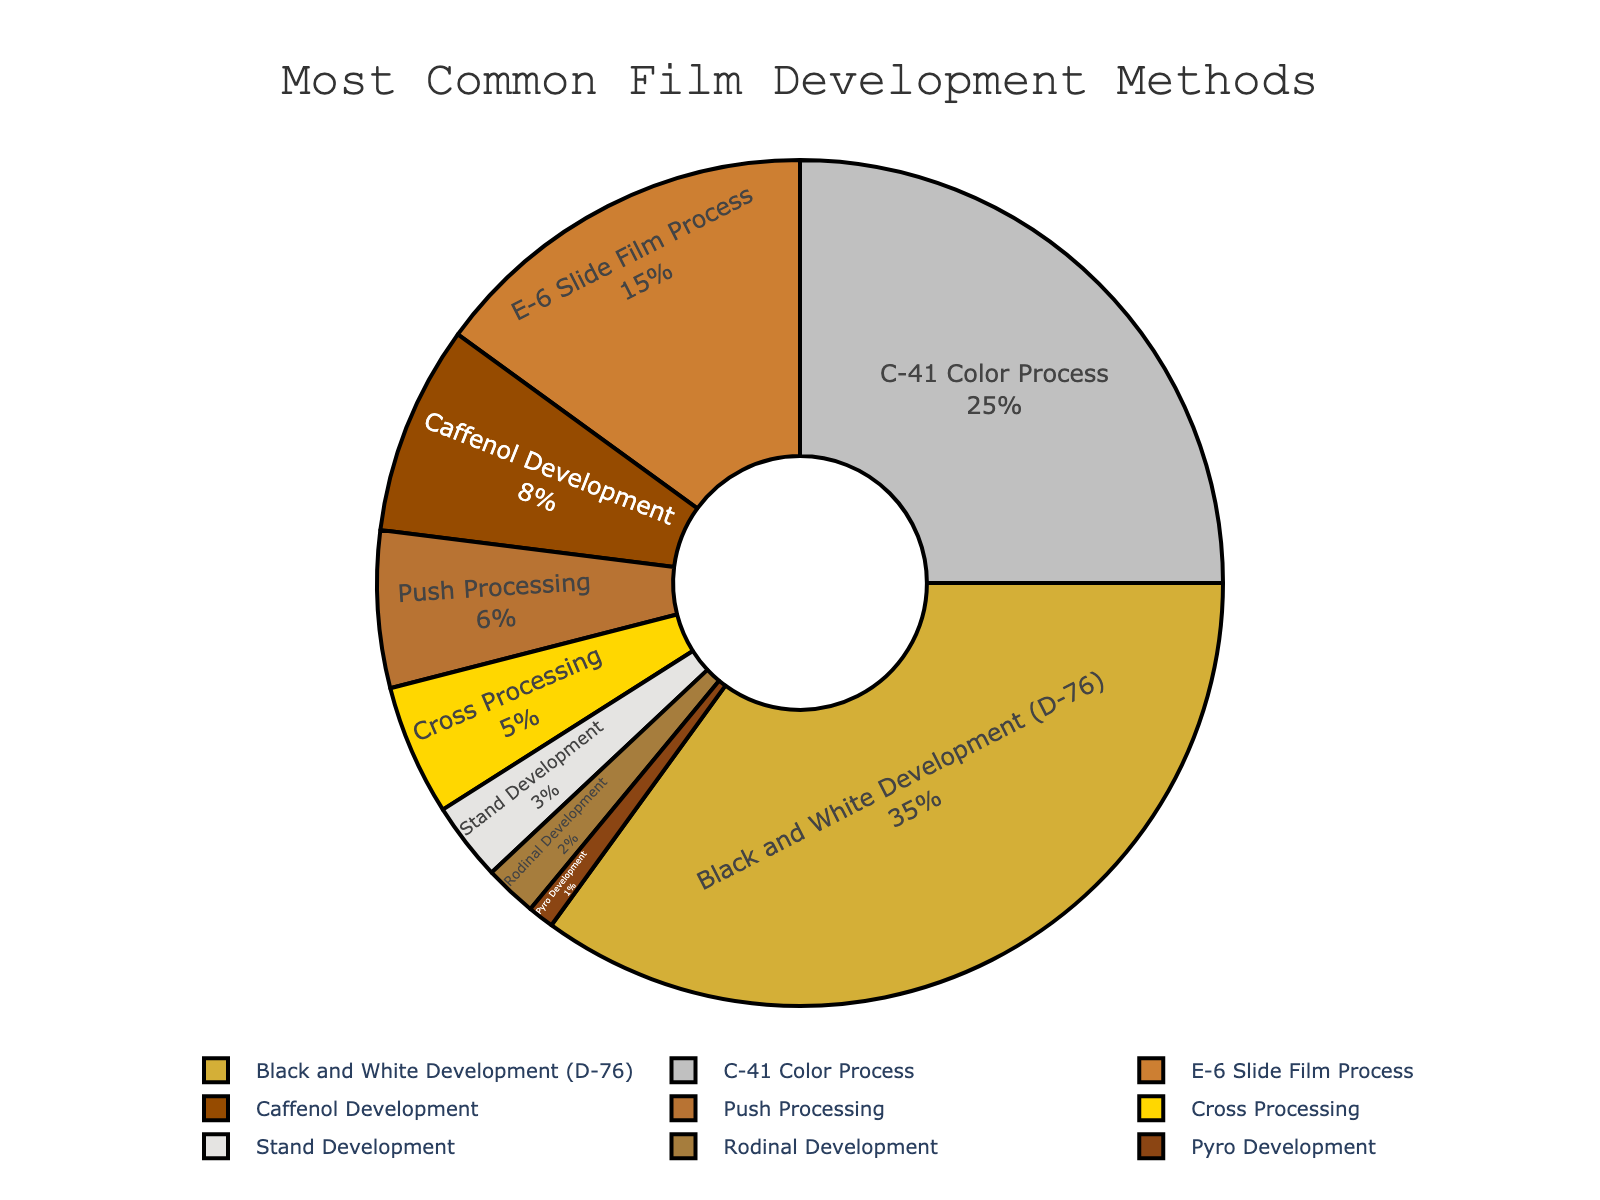Which film development method is the most common among hobbyists? The chart shows that the Black and White Development (D-76) method has the largest portion of the pie, indicating it's the most common.
Answer: Black and White Development (D-76) Which two methods combined represent the highest percentage of usage? Adding the percentages of the Black and White Development (D-76) and C-41 Color Process, which are the two largest sections, results in 35% + 25% = 60%.
Answer: Black and White Development (D-76) and C-41 Color Process How much more popular is the Caffenol Development than the Rodinal Development? Subtract the percentage of Rodinal Development from Caffenol Development: 8% - 2% = 6%.
Answer: 6% What percentage of hobbyists use either the Push Processing or Cross Processing methods? Adding the percentages of Push Processing (6%) and Cross Processing (5%), we get 6% + 5% = 11%.
Answer: 11% If Stand Development and Pyro Development were combined, would their total be more or less than Caffenol Development? Summing the percentages of Stand Development (3%) and Pyro Development (1%) gives 3% + 1% = 4%, which is less than Caffenol Development's 8%.
Answer: Less Which method has the smallest percentage of hobbyists using it? The chart indicates that Pyro Development has the smallest section, showing 1%.
Answer: Pyro Development By how much does the usage of the E-6 Slide Film Process exceed that of the Stand Development method? Subtract the percentage of Stand Development from E-6 Slide Film Process: 15% - 3% = 12%.
Answer: 12% Is Cross Processing more popular than Push Processing? The chart shows that Push Processing (6%) is more popular than Cross Processing (5%).
Answer: No What is the combined percentage of all the less commonly used development methods (those with less than 10% each)? Sum the percentages of Caffenol Development (8%), Push Processing (6%), Cross Processing (5%), Stand Development (3%), Rodinal Development (2%), and Pyro Development (1%): 8% + 6% + 5% + 3% + 2% + 1% = 25%.
Answer: 25% What is the average percentage of usage for the C-41 Color Process and E-6 Slide Film Process? Sum the percentages of C-41 Color Process (25%) and E-6 Slide Film Process (15%), then divide by 2: (25% + 15%) / 2 = 20%.
Answer: 20% 